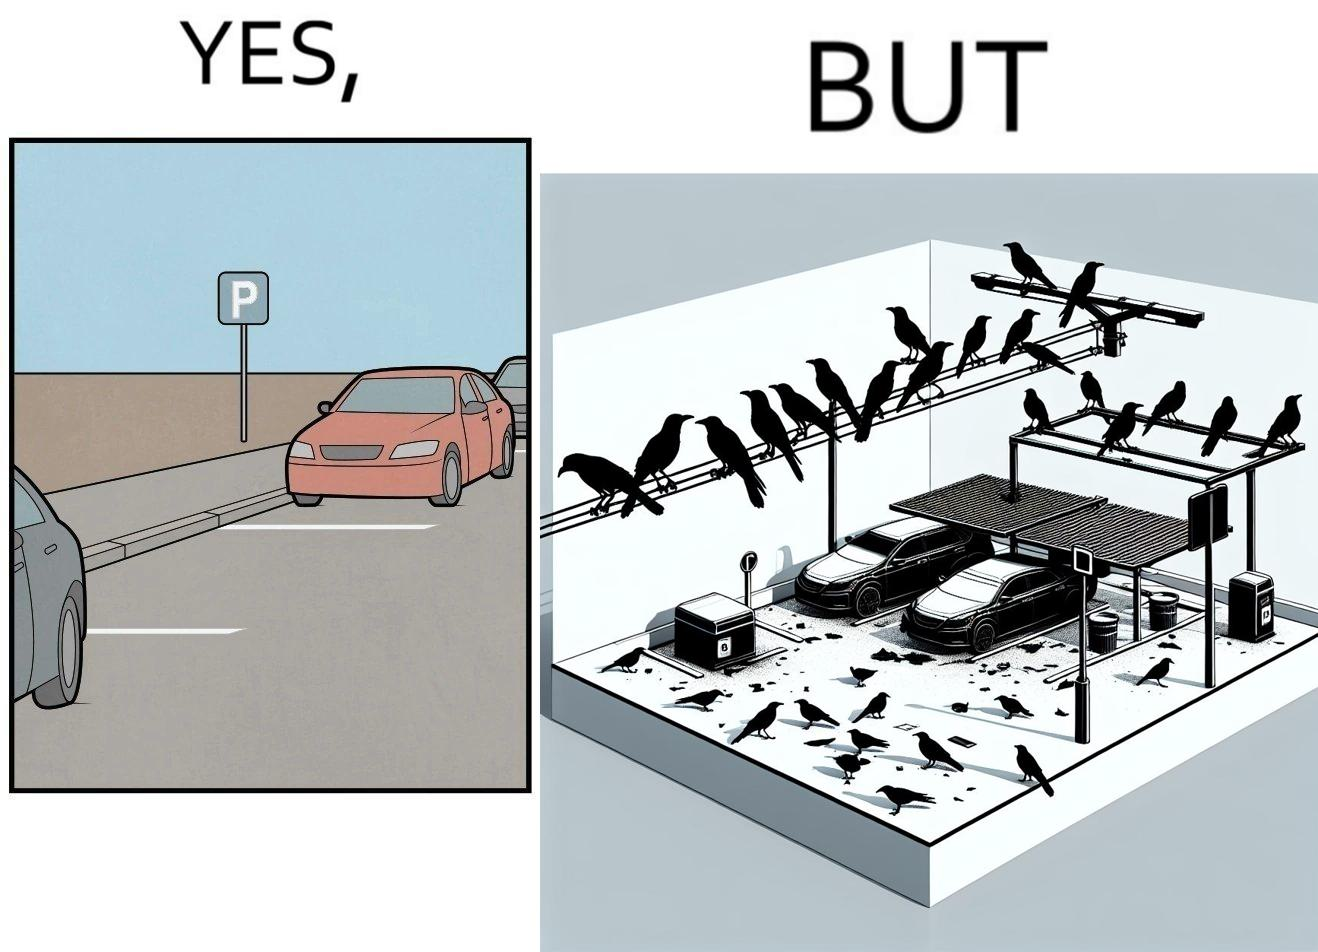What is shown in this image? The image is ironical such that although there is a place for parking but that place is not suitable because if we place our car there then our car will become dirty from top due to crow beet. 